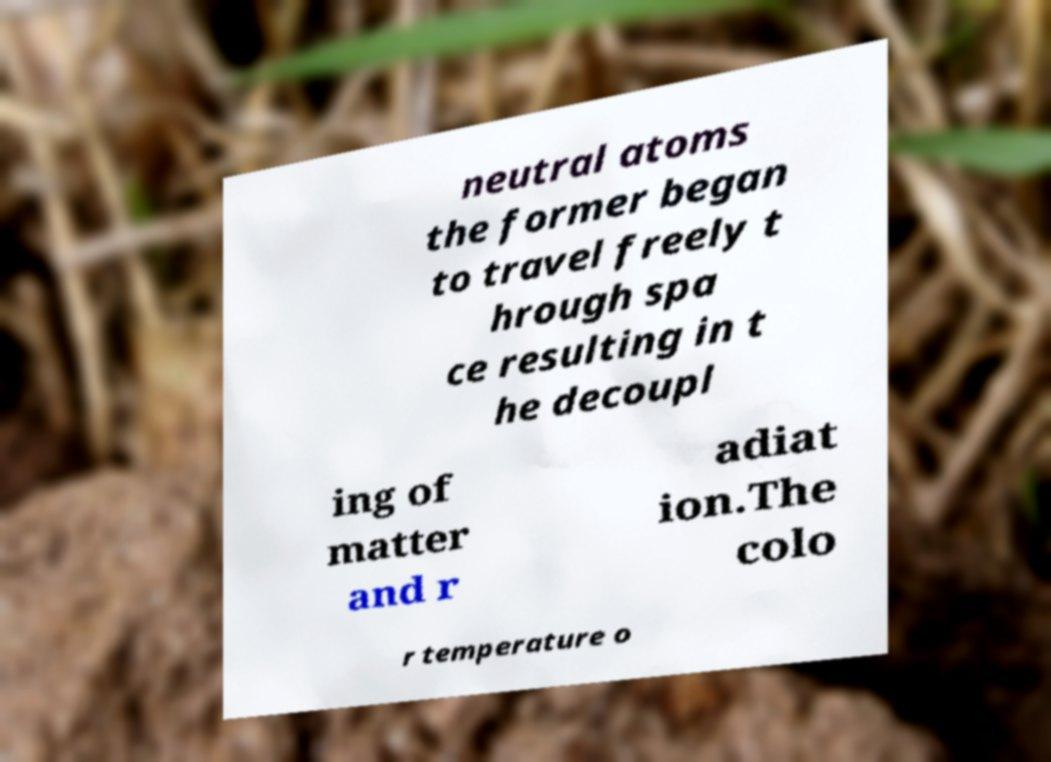I need the written content from this picture converted into text. Can you do that? neutral atoms the former began to travel freely t hrough spa ce resulting in t he decoupl ing of matter and r adiat ion.The colo r temperature o 